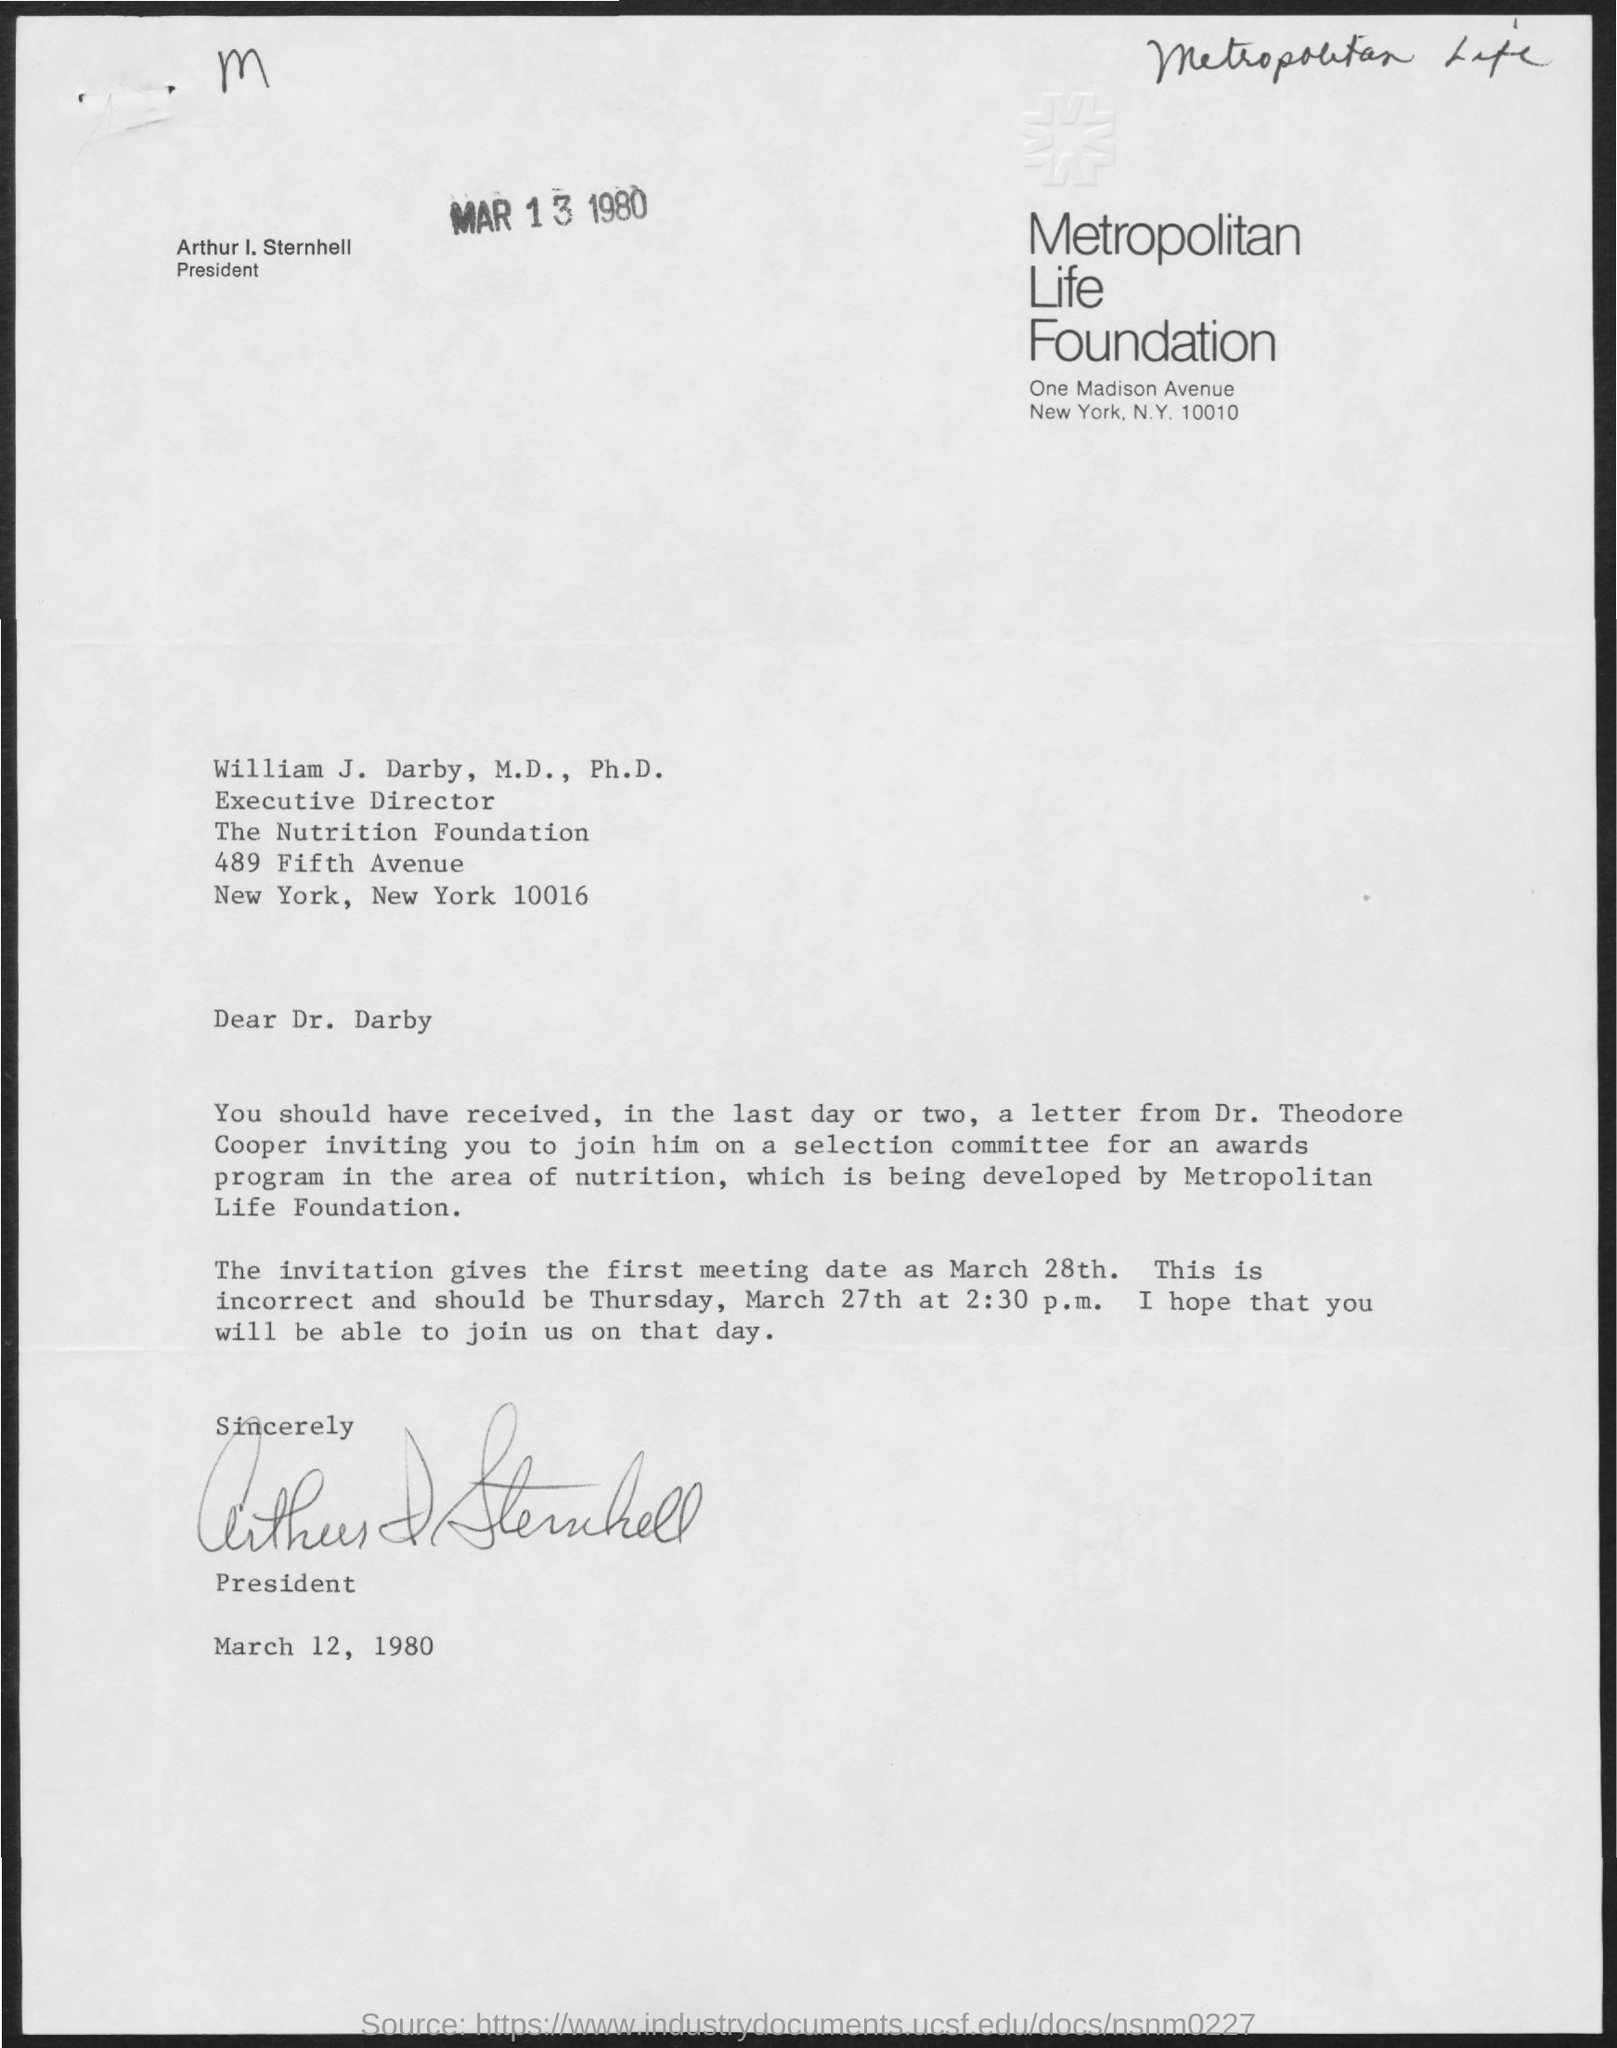Point out several critical features in this image. At the top-right of the document, the text Metropolitan Life is written. Arthur I. Sternhell is the President. The date at the bottom of the document is March 12, 1980. The date at the top of the document is MAR 13 1980. The letter located at the top-left corner of the document is 'M'. 